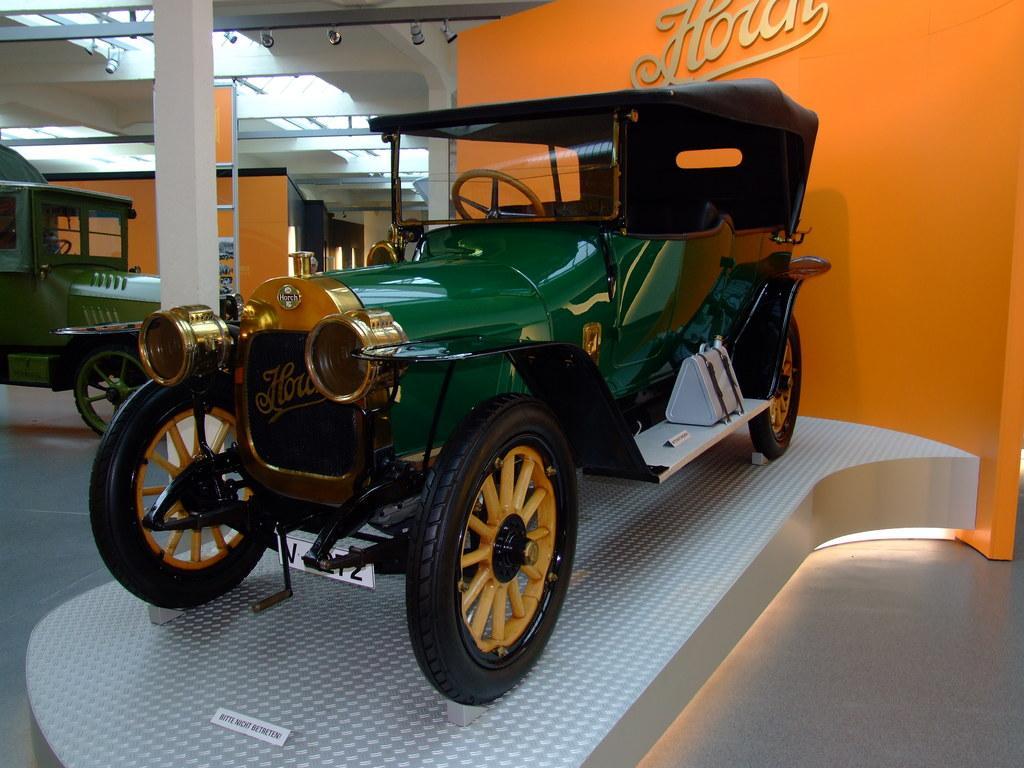How would you summarize this image in a sentence or two? In this image we can see green color vehicle on the white platform. Background of the image, one more vehicle is there. We can see orange color walls and white color pillar with white roof. 